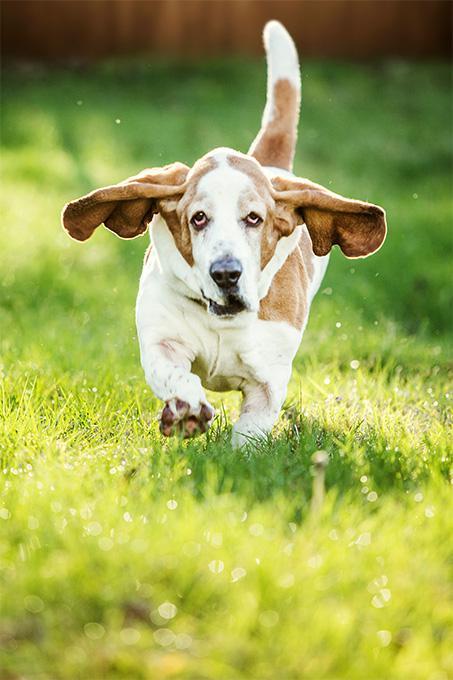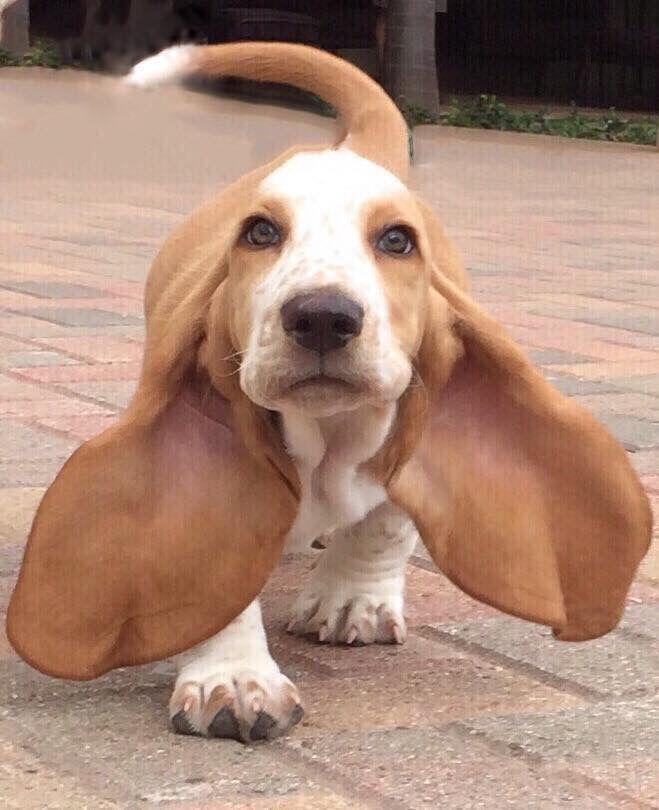The first image is the image on the left, the second image is the image on the right. Analyze the images presented: Is the assertion "The dog in one of the images is running toward the camera." valid? Answer yes or no. Yes. 